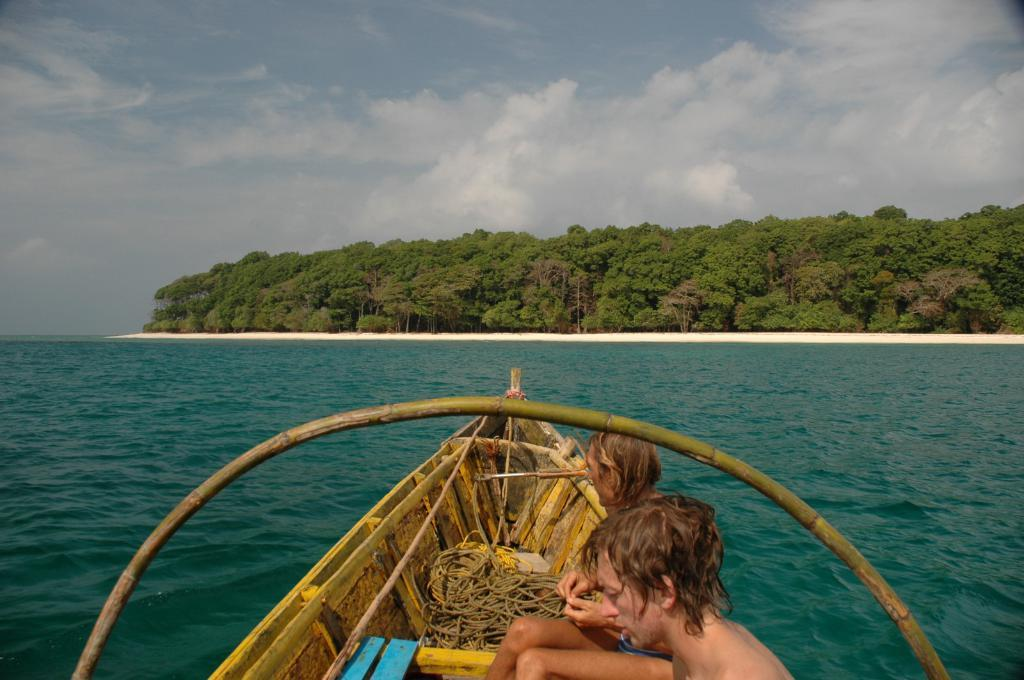How many people are in the image? There are two persons in the image. What are the persons doing in the image? The persons are sitting on a boat. Where is the boat located in the image? The boat is on the water. What can be seen in the background of the image? There are trees and the sky visible in the image. What type of stick is being used to paste the trees in the image? There is no stick or pasting activity present in the image. The trees are naturally growing, and no such activity is depicted. 